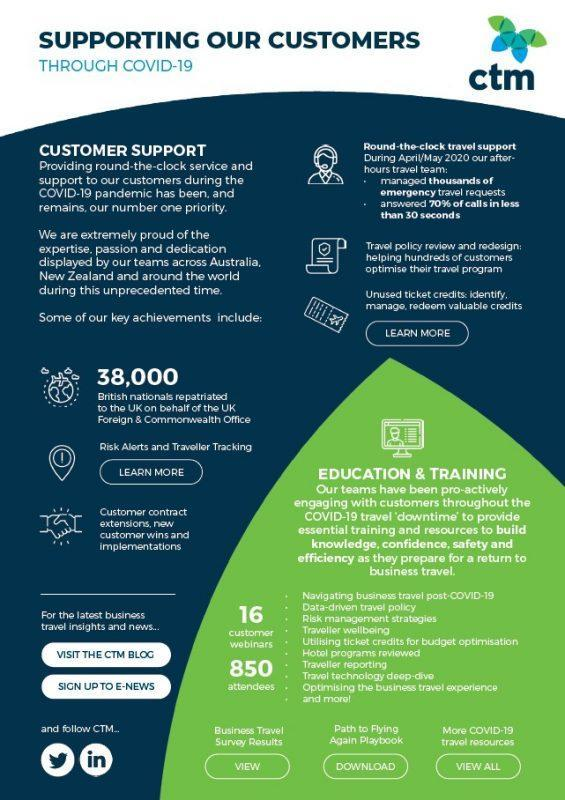What is the number of attendees?
Answer the question with a short phrase. 850 What is the number of customer webinars? 16 How many British nationals repatriated to the UK? 38,000 